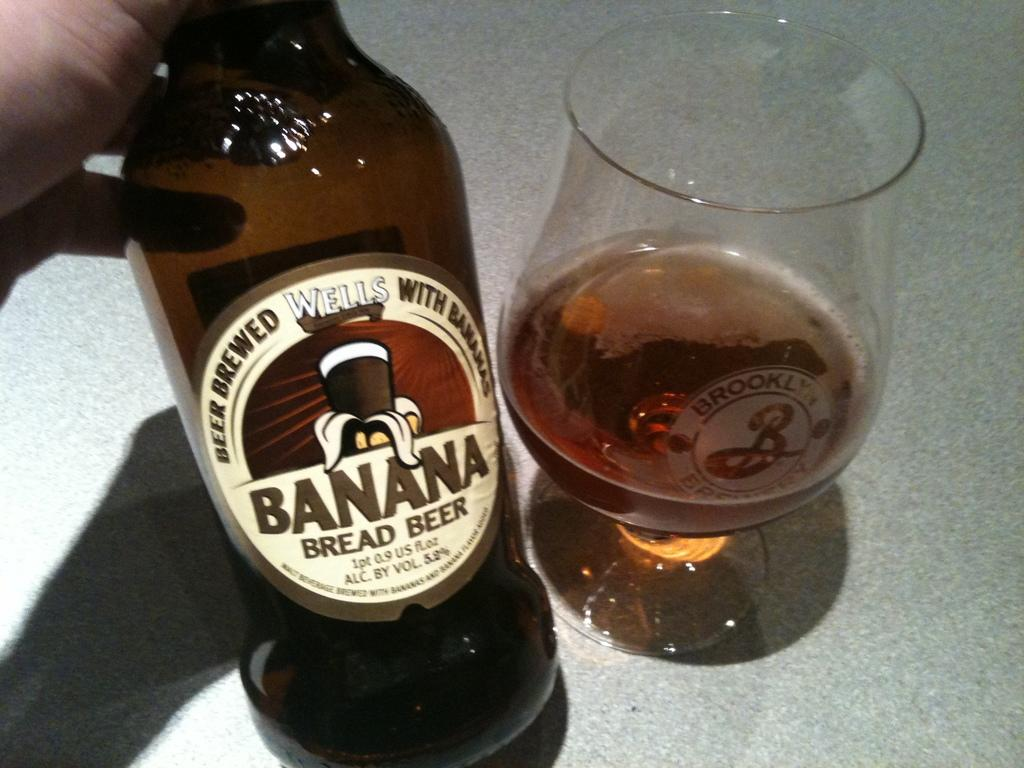<image>
Describe the image concisely. A bottle of Banana Bread Beer is being held near a glass. 